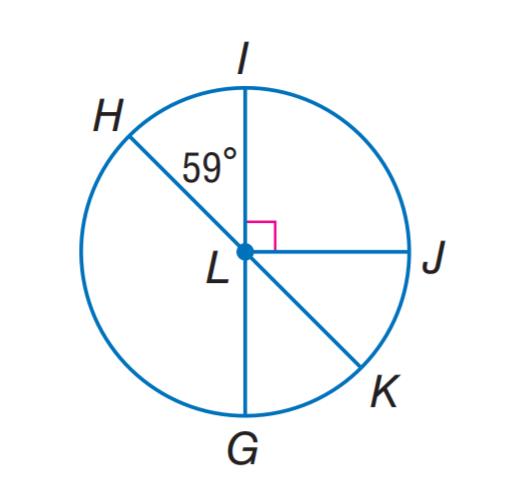Answer the mathemtical geometry problem and directly provide the correct option letter.
Question: H K and I G are diameters of \odot L. Find m \widehat H I.
Choices: A: 31 B: 59 C: 65 D: 135 B 